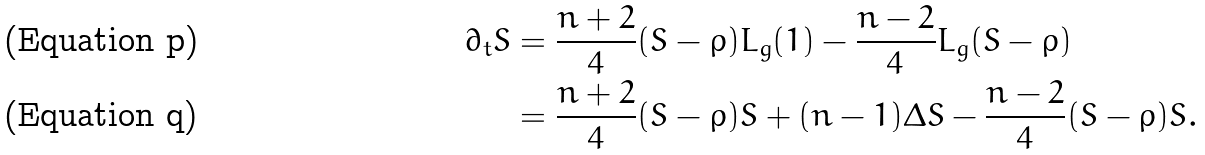<formula> <loc_0><loc_0><loc_500><loc_500>\partial _ { t } S & = \frac { n + 2 } { 4 } ( S - \rho ) L _ { g } ( 1 ) - \frac { n - 2 } { 4 } L _ { g } ( S - \rho ) \\ & = \frac { n + 2 } { 4 } ( S - \rho ) S + ( n - 1 ) \Delta S - \frac { n - 2 } { 4 } ( S - \rho ) S .</formula> 